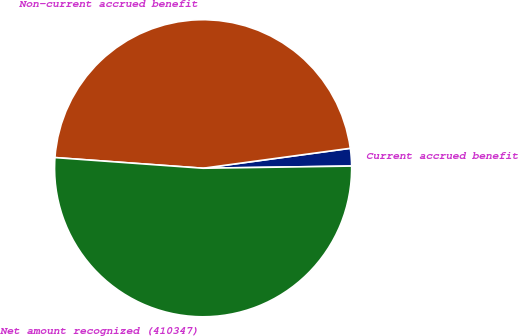Convert chart to OTSL. <chart><loc_0><loc_0><loc_500><loc_500><pie_chart><fcel>Current accrued benefit<fcel>Non-current accrued benefit<fcel>Net amount recognized (410347)<nl><fcel>1.91%<fcel>46.71%<fcel>51.38%<nl></chart> 